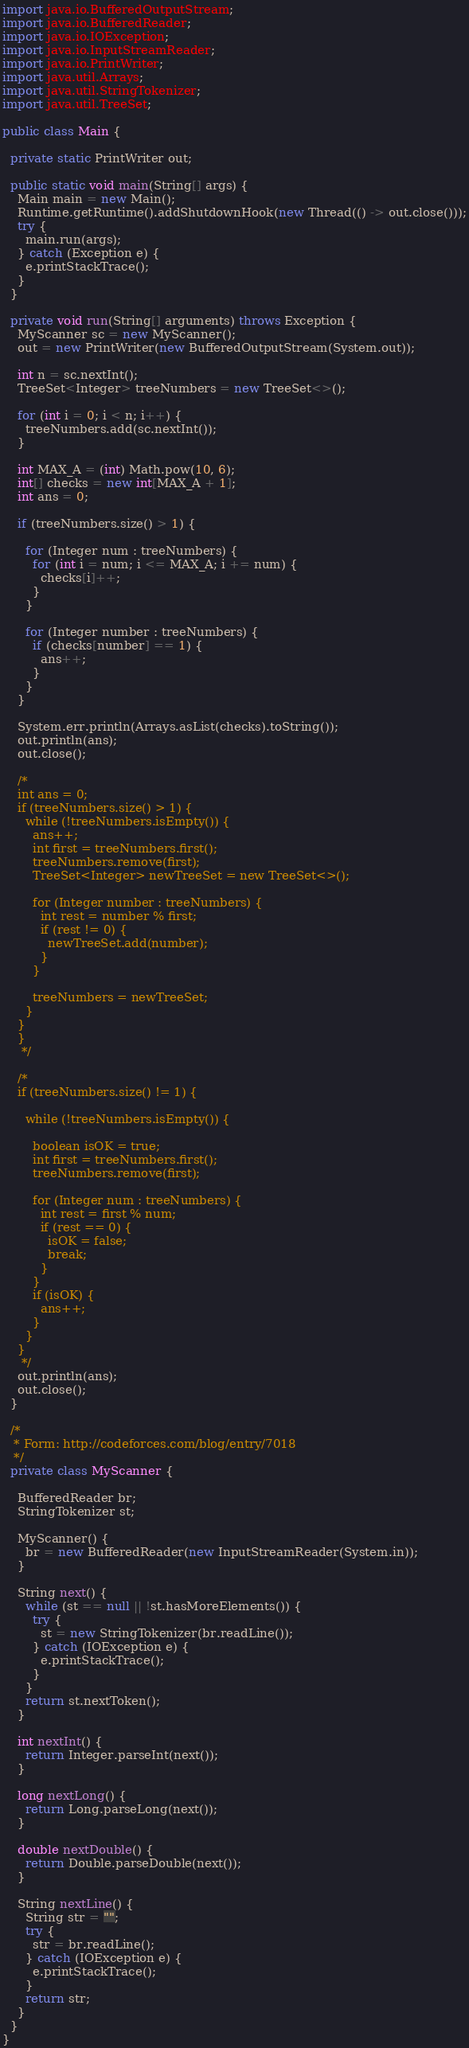<code> <loc_0><loc_0><loc_500><loc_500><_Java_>import java.io.BufferedOutputStream;
import java.io.BufferedReader;
import java.io.IOException;
import java.io.InputStreamReader;
import java.io.PrintWriter;
import java.util.Arrays;
import java.util.StringTokenizer;
import java.util.TreeSet;

public class Main {

  private static PrintWriter out;

  public static void main(String[] args) {
    Main main = new Main();
    Runtime.getRuntime().addShutdownHook(new Thread(() -> out.close()));
    try {
      main.run(args);
    } catch (Exception e) {
      e.printStackTrace();
    }
  }

  private void run(String[] arguments) throws Exception {
    MyScanner sc = new MyScanner();
    out = new PrintWriter(new BufferedOutputStream(System.out));

    int n = sc.nextInt();
    TreeSet<Integer> treeNumbers = new TreeSet<>();

    for (int i = 0; i < n; i++) {
      treeNumbers.add(sc.nextInt());
    }

    int MAX_A = (int) Math.pow(10, 6);
    int[] checks = new int[MAX_A + 1];
    int ans = 0;

    if (treeNumbers.size() > 1) {

      for (Integer num : treeNumbers) {
        for (int i = num; i <= MAX_A; i += num) {
          checks[i]++;
        }
      }

      for (Integer number : treeNumbers) {
        if (checks[number] == 1) {
          ans++;
        }
      }
    }

    System.err.println(Arrays.asList(checks).toString());
    out.println(ans);
    out.close();

    /*
    int ans = 0;
    if (treeNumbers.size() > 1) {
      while (!treeNumbers.isEmpty()) {
        ans++;
        int first = treeNumbers.first();
        treeNumbers.remove(first);
        TreeSet<Integer> newTreeSet = new TreeSet<>();

        for (Integer number : treeNumbers) {
          int rest = number % first;
          if (rest != 0) {
            newTreeSet.add(number);
          }
        }

        treeNumbers = newTreeSet;
      }
    }
    }
     */

    /*
    if (treeNumbers.size() != 1) {

      while (!treeNumbers.isEmpty()) {

        boolean isOK = true;
        int first = treeNumbers.first();
        treeNumbers.remove(first);

        for (Integer num : treeNumbers) {
          int rest = first % num;
          if (rest == 0) {
            isOK = false;
            break;
          }
        }
        if (isOK) {
          ans++;
        }
      }
    }
     */
    out.println(ans);
    out.close();
  }

  /*
   * Form: http://codeforces.com/blog/entry/7018
   */
  private class MyScanner {

    BufferedReader br;
    StringTokenizer st;

    MyScanner() {
      br = new BufferedReader(new InputStreamReader(System.in));
    }

    String next() {
      while (st == null || !st.hasMoreElements()) {
        try {
          st = new StringTokenizer(br.readLine());
        } catch (IOException e) {
          e.printStackTrace();
        }
      }
      return st.nextToken();
    }

    int nextInt() {
      return Integer.parseInt(next());
    }

    long nextLong() {
      return Long.parseLong(next());
    }

    double nextDouble() {
      return Double.parseDouble(next());
    }

    String nextLine() {
      String str = "";
      try {
        str = br.readLine();
      } catch (IOException e) {
        e.printStackTrace();
      }
      return str;
    }
  }
}
</code> 